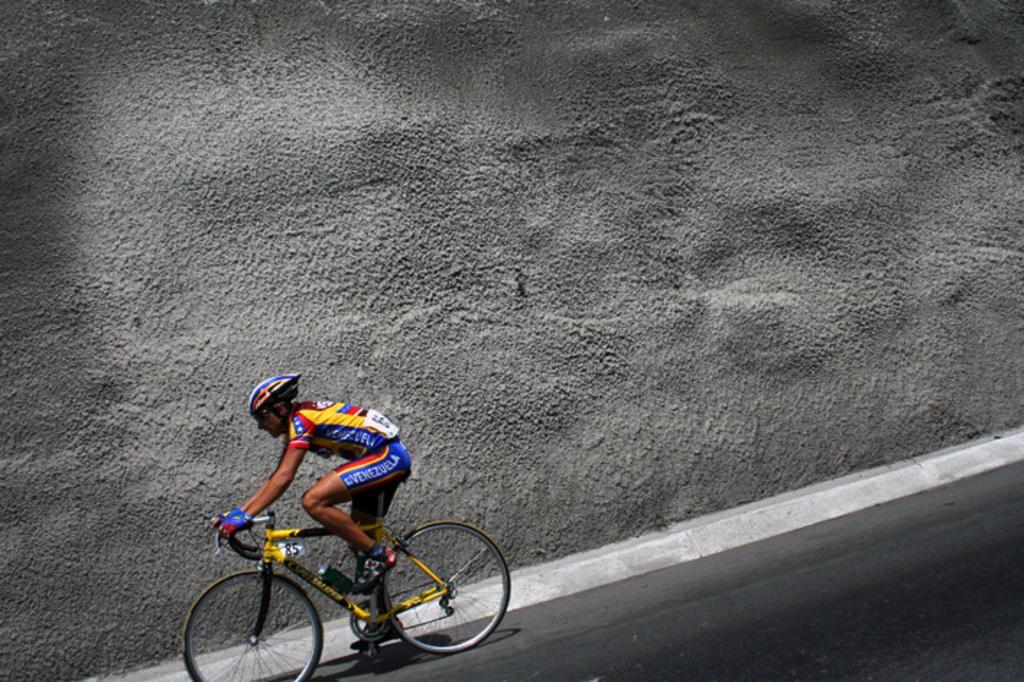Could you give a brief overview of what you see in this image? In this picture there is a man sitting and riding bicycle on the road and wore helmet and gloves. In the background of the image we can see wall. 